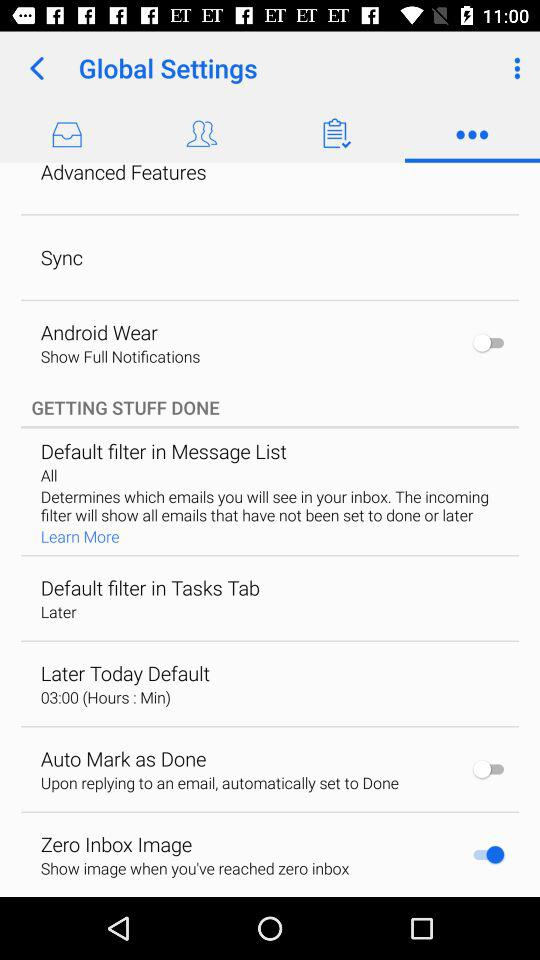What is the setting for the zero inbox image? The setting is "Show image when you've reached zero inbox". 